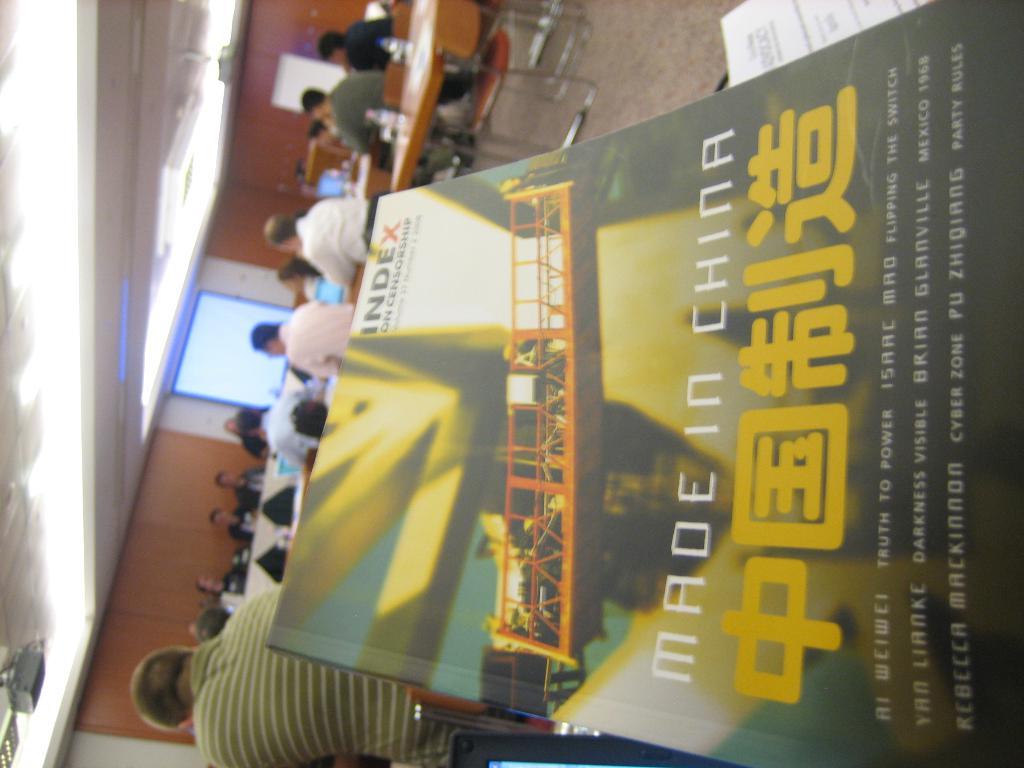Where was this product made?
Ensure brevity in your answer.  China. What is the title of the book (full)?
Your answer should be compact. Made in china. 